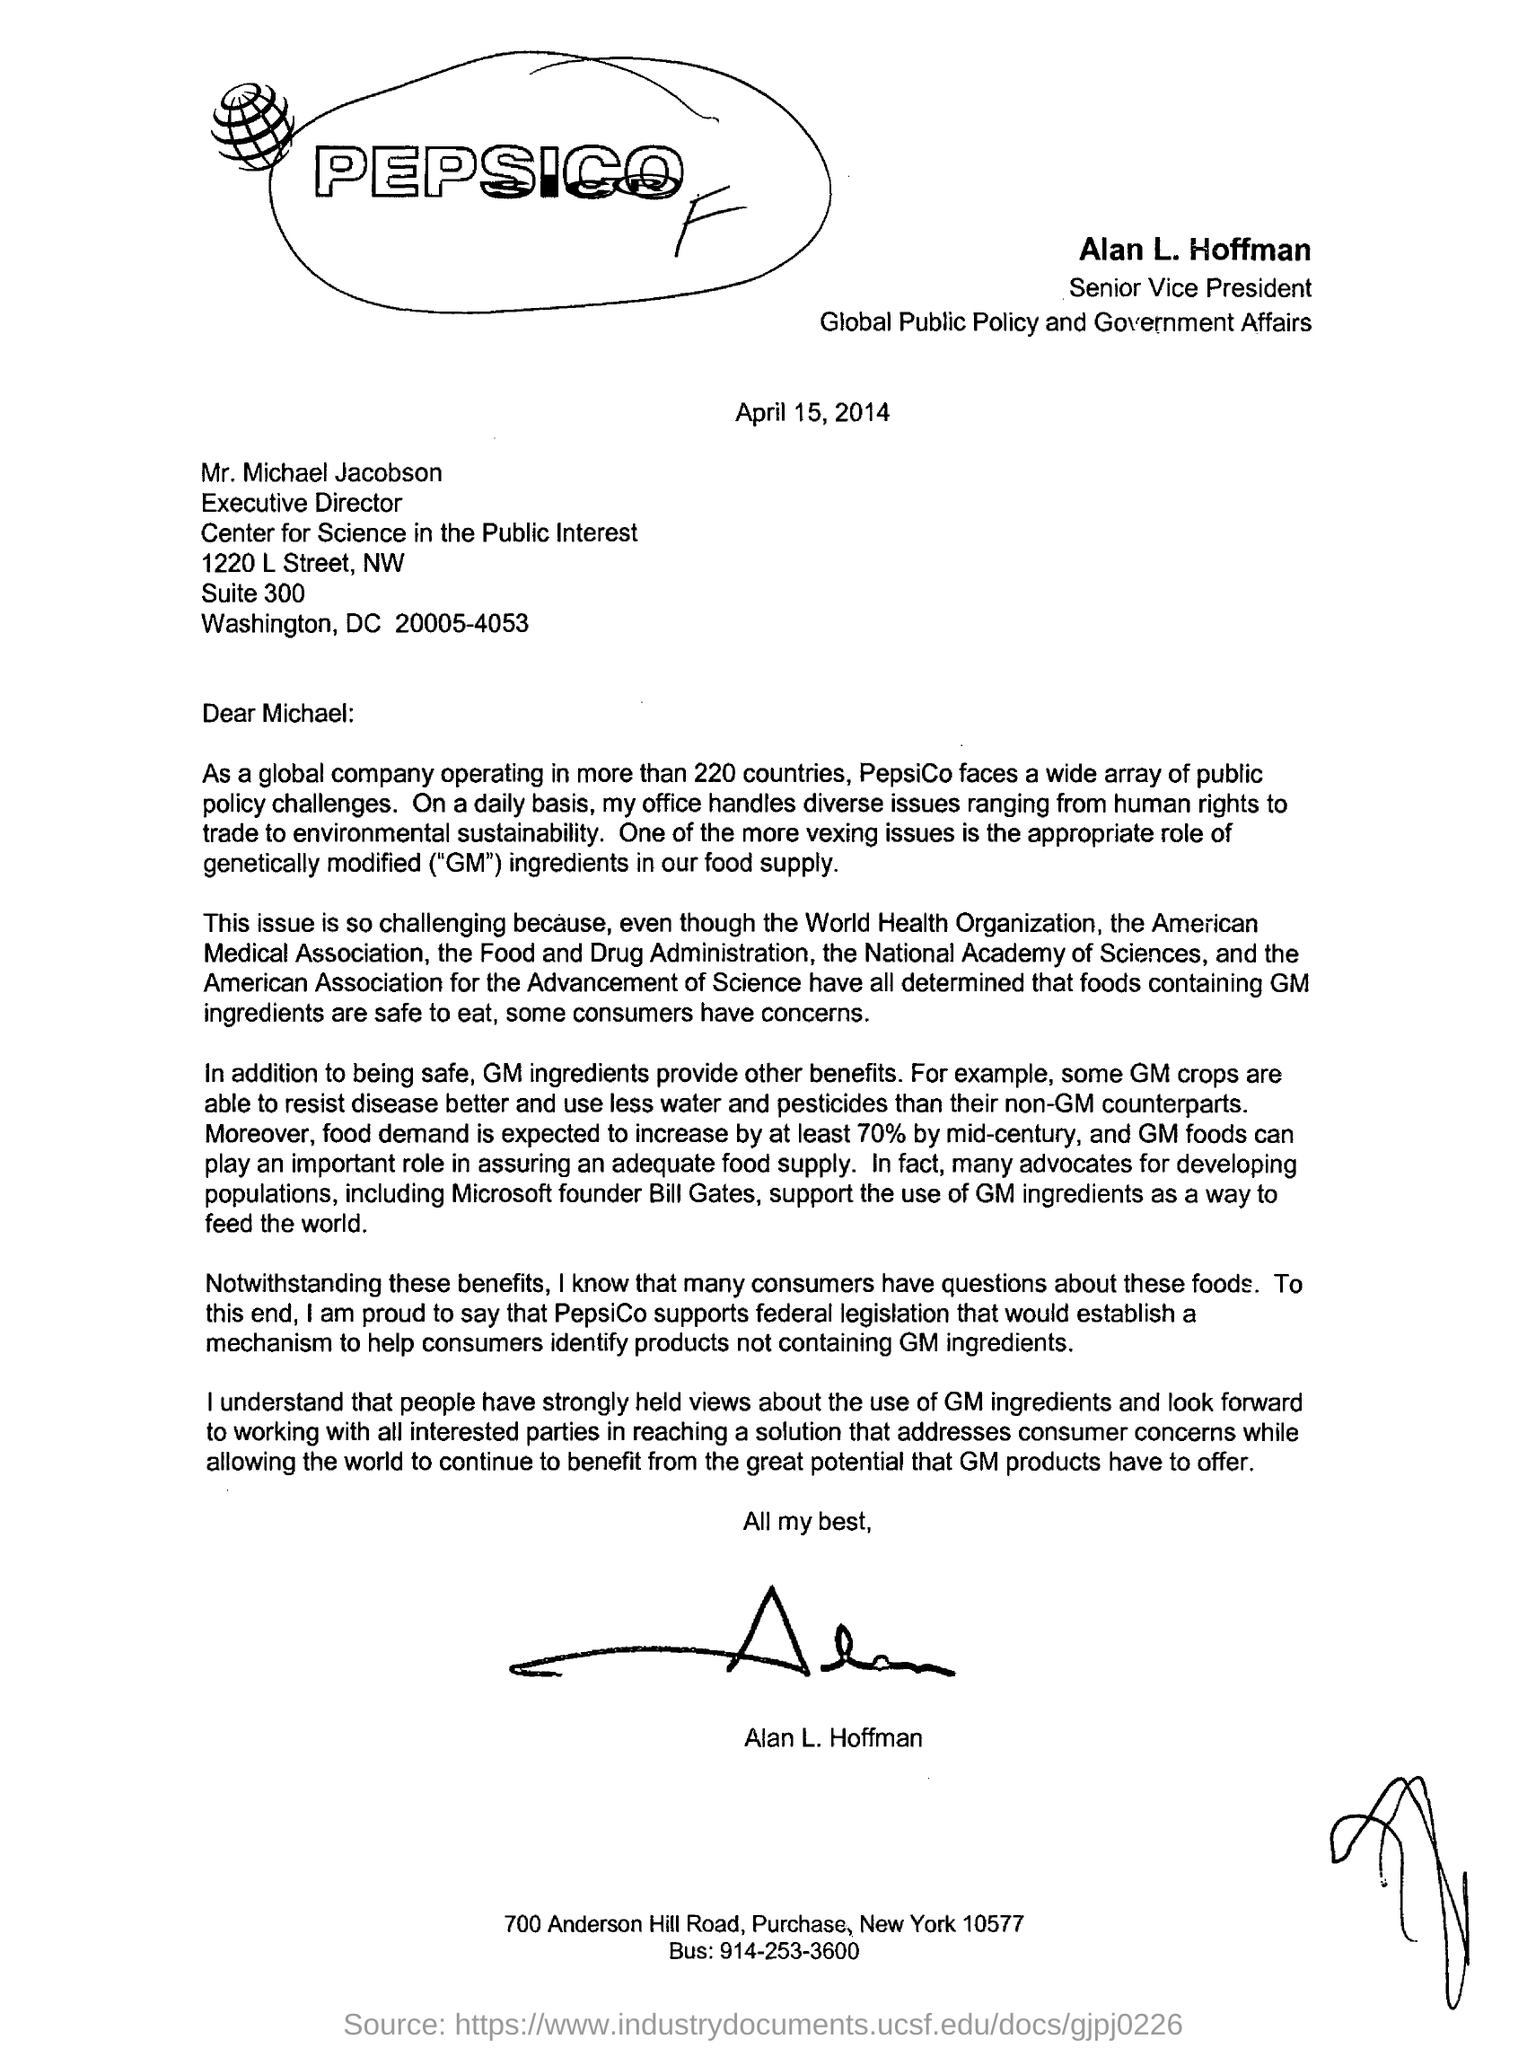Who is the senior vice president ?
Give a very brief answer. Alan L. Hoffman. What is the date mentioned in the letter?
Offer a very short reply. April 15, 2014. Who is the executive director?
Offer a very short reply. Mr. Michael jacobson. Where is alan l.hoffan working ?
Ensure brevity in your answer.  Global public policy and government affairs. In how many countries global company is operating ?
Your answer should be compact. More than 220. 